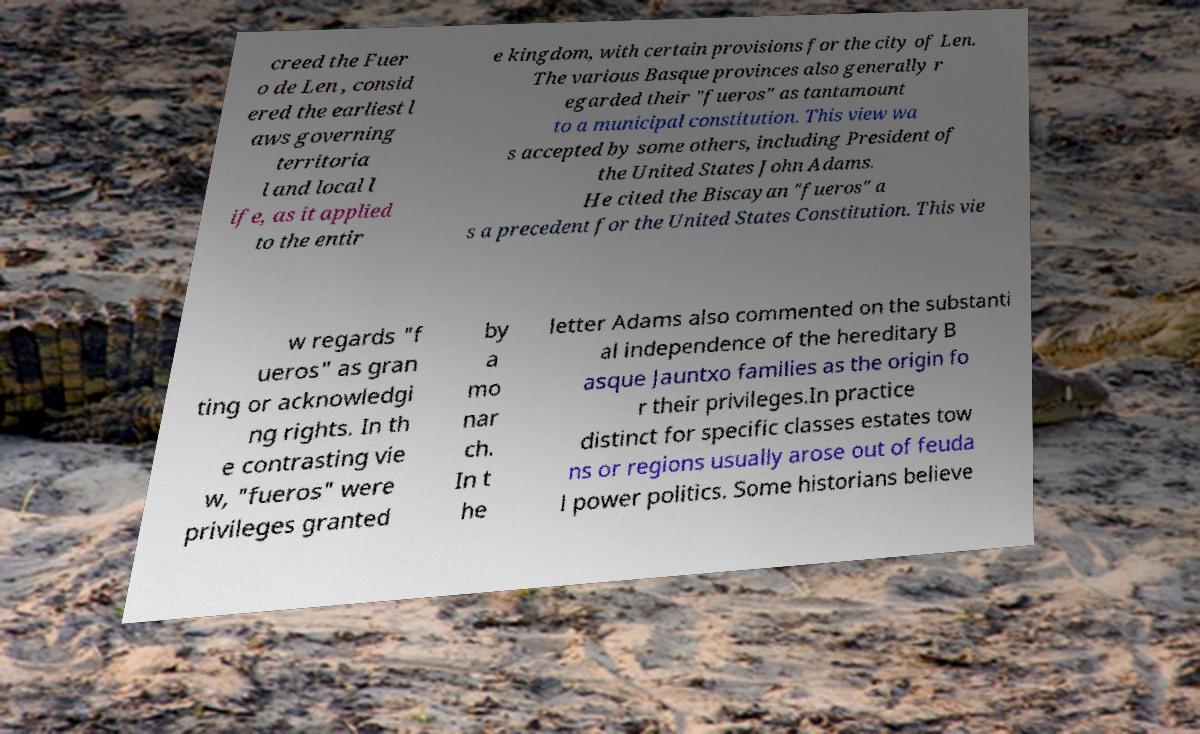Can you accurately transcribe the text from the provided image for me? creed the Fuer o de Len , consid ered the earliest l aws governing territoria l and local l ife, as it applied to the entir e kingdom, with certain provisions for the city of Len. The various Basque provinces also generally r egarded their "fueros" as tantamount to a municipal constitution. This view wa s accepted by some others, including President of the United States John Adams. He cited the Biscayan "fueros" a s a precedent for the United States Constitution. This vie w regards "f ueros" as gran ting or acknowledgi ng rights. In th e contrasting vie w, "fueros" were privileges granted by a mo nar ch. In t he letter Adams also commented on the substanti al independence of the hereditary B asque Jauntxo families as the origin fo r their privileges.In practice distinct for specific classes estates tow ns or regions usually arose out of feuda l power politics. Some historians believe 